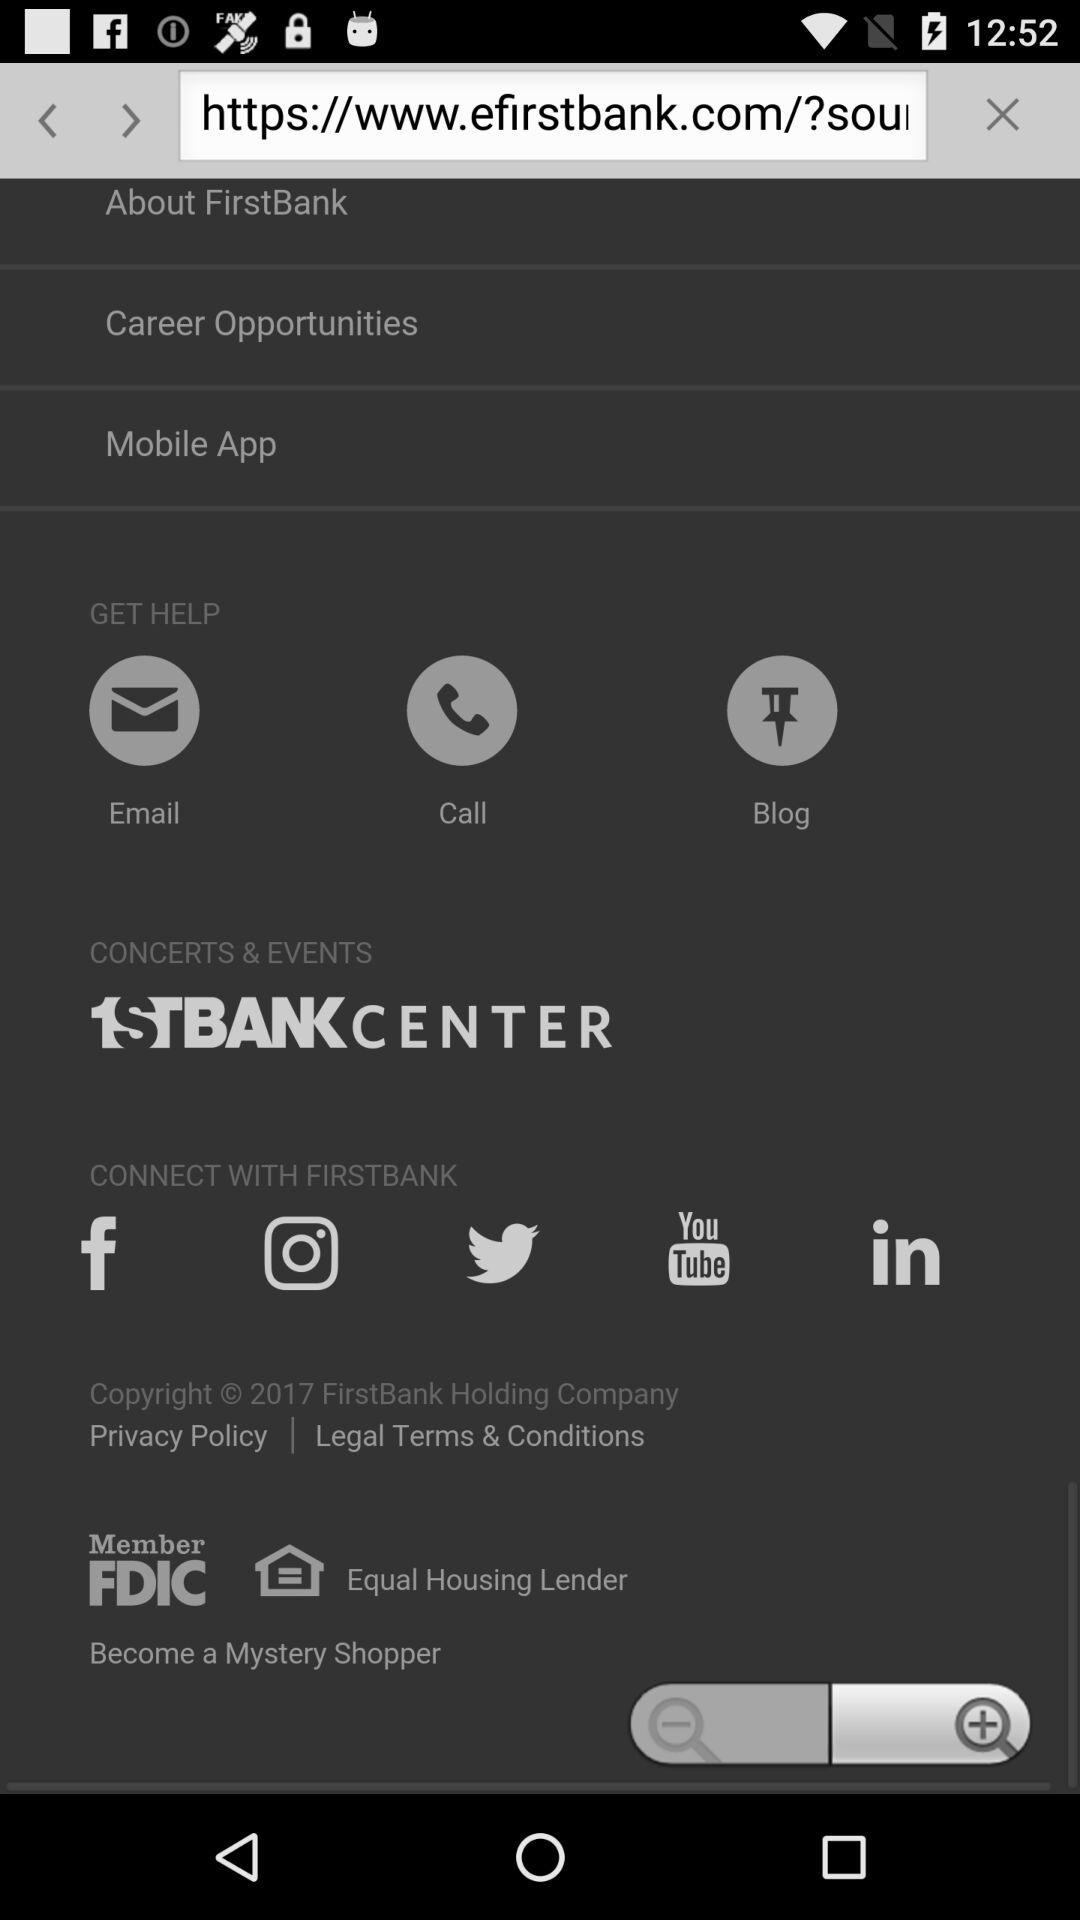What are the options for getting help? You can get help through email, calls, and blogs. 